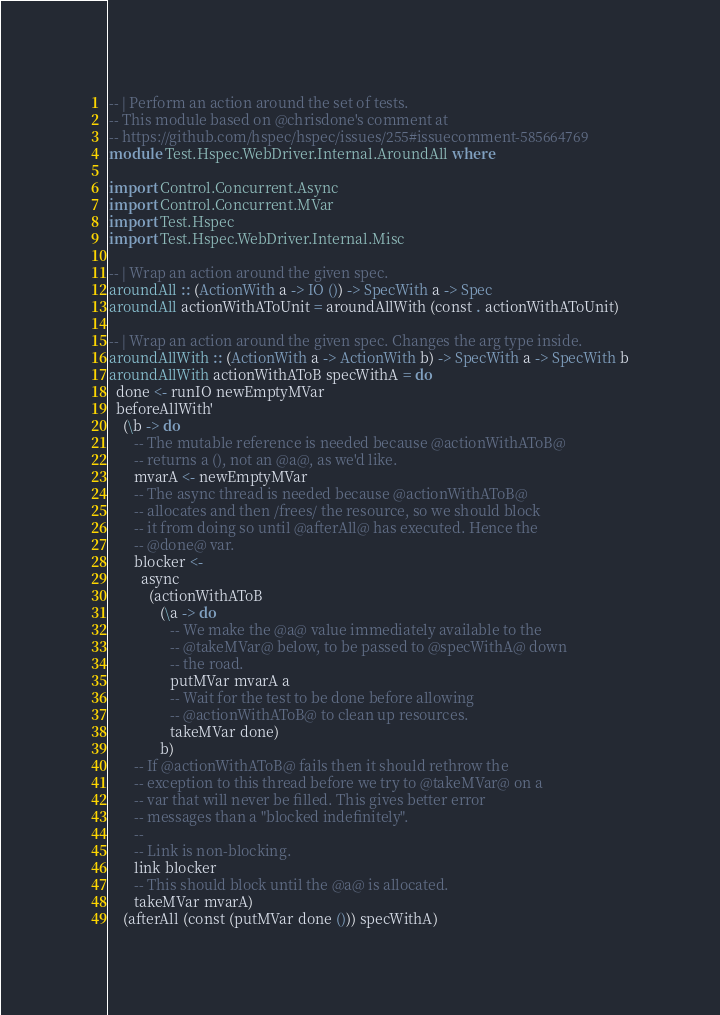Convert code to text. <code><loc_0><loc_0><loc_500><loc_500><_Haskell_>-- | Perform an action around the set of tests.
-- This module based on @chrisdone's comment at
-- https://github.com/hspec/hspec/issues/255#issuecomment-585664769
module Test.Hspec.WebDriver.Internal.AroundAll where

import Control.Concurrent.Async
import Control.Concurrent.MVar
import Test.Hspec
import Test.Hspec.WebDriver.Internal.Misc

-- | Wrap an action around the given spec.
aroundAll :: (ActionWith a -> IO ()) -> SpecWith a -> Spec
aroundAll actionWithAToUnit = aroundAllWith (const . actionWithAToUnit)

-- | Wrap an action around the given spec. Changes the arg type inside.
aroundAllWith :: (ActionWith a -> ActionWith b) -> SpecWith a -> SpecWith b
aroundAllWith actionWithAToB specWithA = do
  done <- runIO newEmptyMVar
  beforeAllWith'
    (\b -> do
       -- The mutable reference is needed because @actionWithAToB@
       -- returns a (), not an @a@, as we'd like.
       mvarA <- newEmptyMVar
       -- The async thread is needed because @actionWithAToB@
       -- allocates and then /frees/ the resource, so we should block
       -- it from doing so until @afterAll@ has executed. Hence the
       -- @done@ var.
       blocker <-
         async
           (actionWithAToB
              (\a -> do
                 -- We make the @a@ value immediately available to the
                 -- @takeMVar@ below, to be passed to @specWithA@ down
                 -- the road.
                 putMVar mvarA a
                 -- Wait for the test to be done before allowing
                 -- @actionWithAToB@ to clean up resources.
                 takeMVar done)
              b)
       -- If @actionWithAToB@ fails then it should rethrow the
       -- exception to this thread before we try to @takeMVar@ on a
       -- var that will never be filled. This gives better error
       -- messages than a "blocked indefinitely".
       --
       -- Link is non-blocking.
       link blocker
       -- This should block until the @a@ is allocated.
       takeMVar mvarA)
    (afterAll (const (putMVar done ())) specWithA)
</code> 